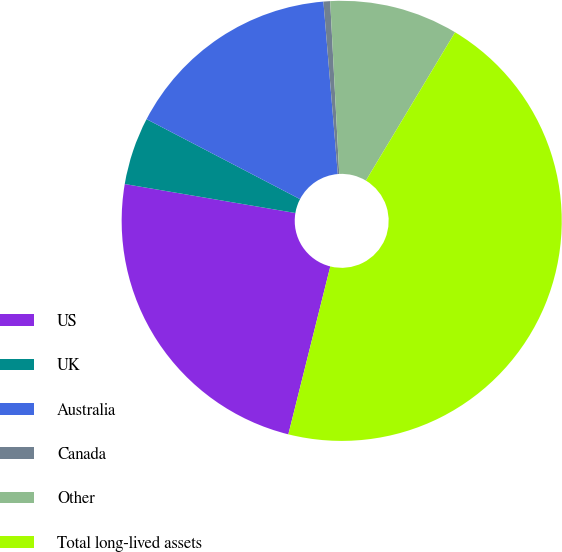Convert chart to OTSL. <chart><loc_0><loc_0><loc_500><loc_500><pie_chart><fcel>US<fcel>UK<fcel>Australia<fcel>Canada<fcel>Other<fcel>Total long-lived assets<nl><fcel>23.78%<fcel>4.97%<fcel>16.03%<fcel>0.49%<fcel>9.45%<fcel>45.28%<nl></chart> 